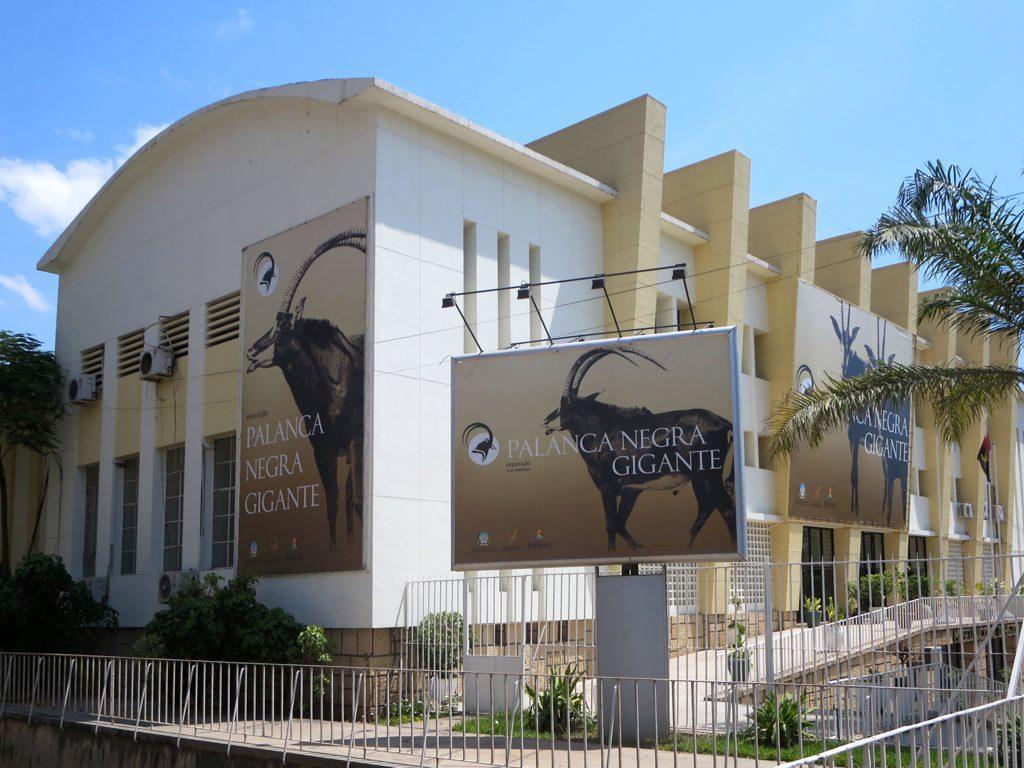Describe this image in one or two sentences. In this image we can see a building, there are windows, air conditioners, there are some boards with text and images on them, there are plants, trees, railings, also we can see the sky. 